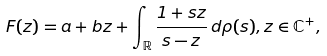<formula> <loc_0><loc_0><loc_500><loc_500>F ( z ) = a + b z + \int _ { \mathbb { R } } \frac { 1 + s z } { s - z } \, d \rho ( s ) , z \in \mathbb { C } ^ { + } ,</formula> 